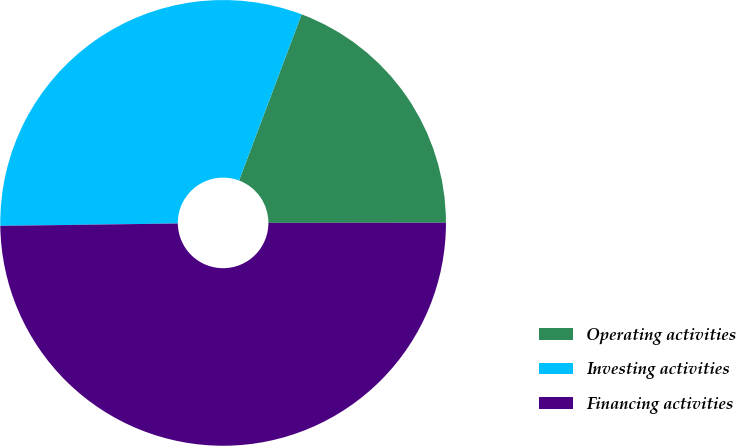Convert chart to OTSL. <chart><loc_0><loc_0><loc_500><loc_500><pie_chart><fcel>Operating activities<fcel>Investing activities<fcel>Financing activities<nl><fcel>19.26%<fcel>30.94%<fcel>49.8%<nl></chart> 